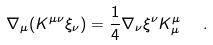<formula> <loc_0><loc_0><loc_500><loc_500>\nabla _ { \mu } ( K ^ { \mu \nu } \xi _ { \nu } ) = \frac { 1 } { 4 } \nabla _ { \nu } \xi ^ { \nu } K ^ { \mu } _ { \mu } \ \ .</formula> 